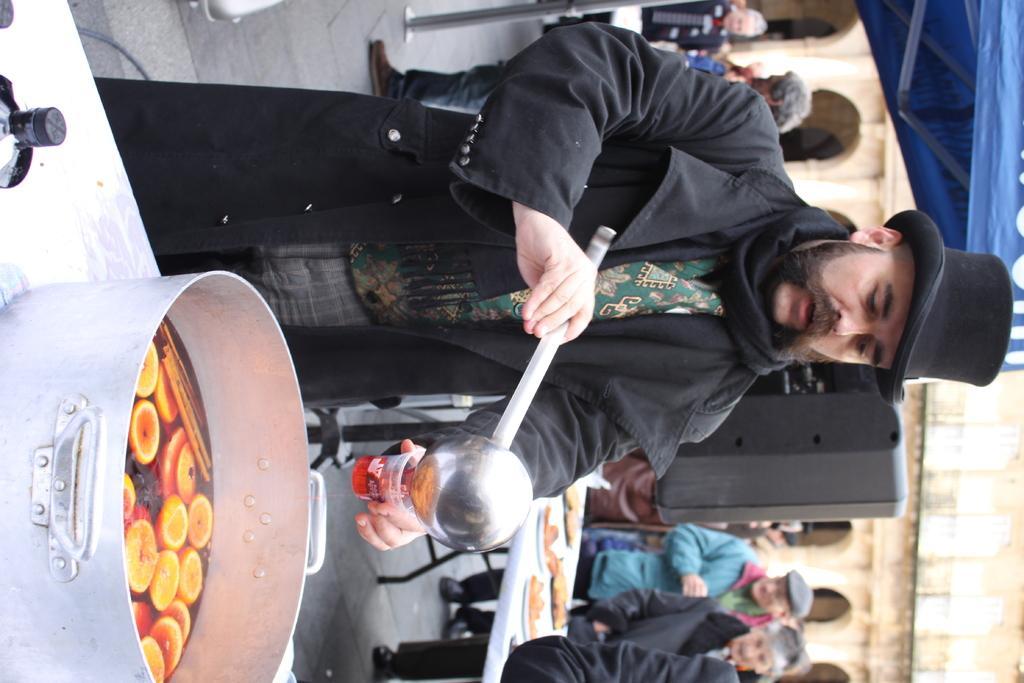How would you summarize this image in a sentence or two? This is a tilted image, in this image on the left side there is a table, on that table there is a bowl, in that bowl there is a food item and people are standing on a road. 